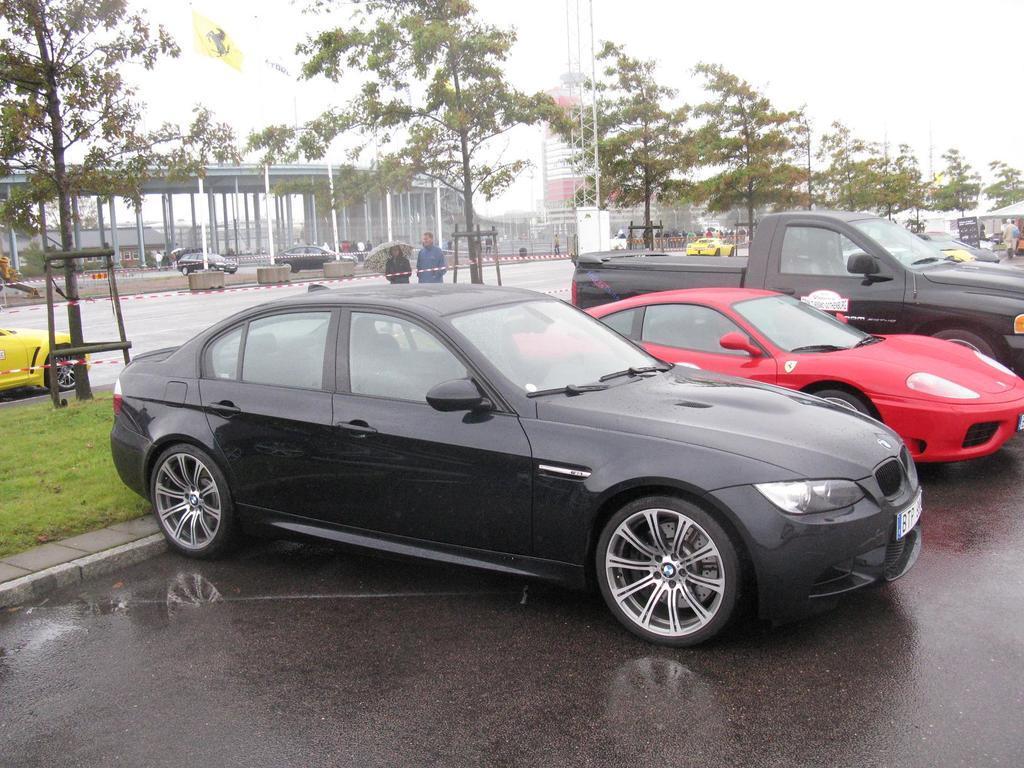Describe this image in one or two sentences. In the center of the image we can see some vehicles, trees, shed, buildings, some persons, poles, tent. At the bottom of the image there is a road. On the left side of the image we can see grass. At the top of the image we can see sky, board. 